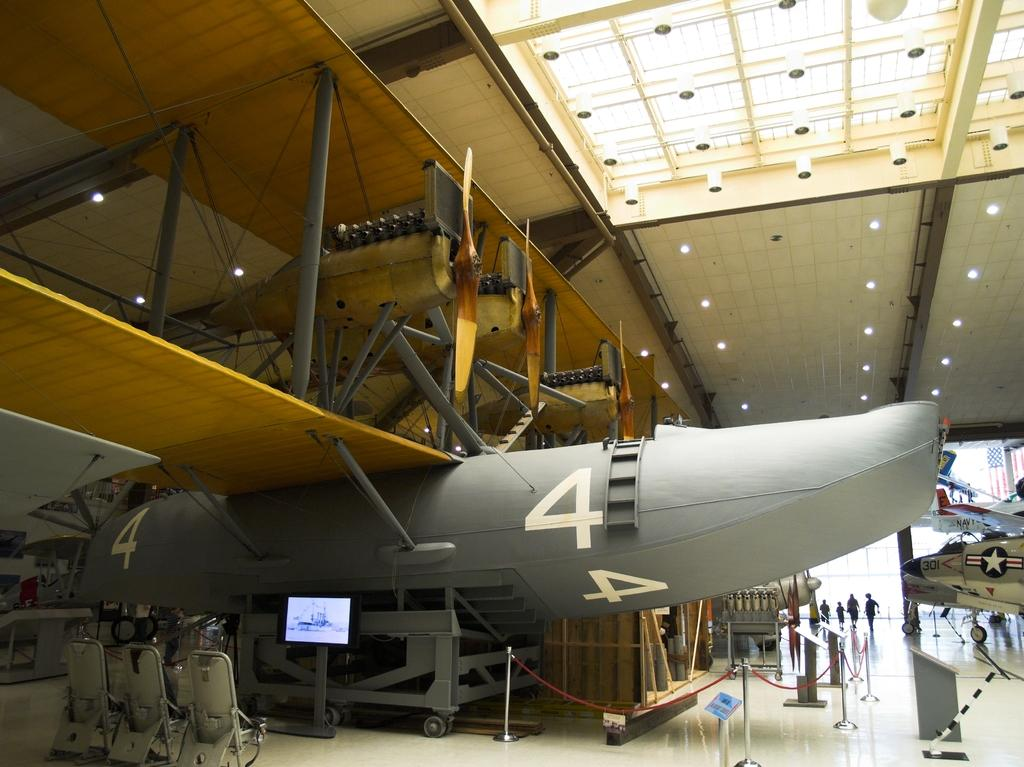<image>
Present a compact description of the photo's key features. An airplane with the number 4 on it in a few places sits inside a building. 